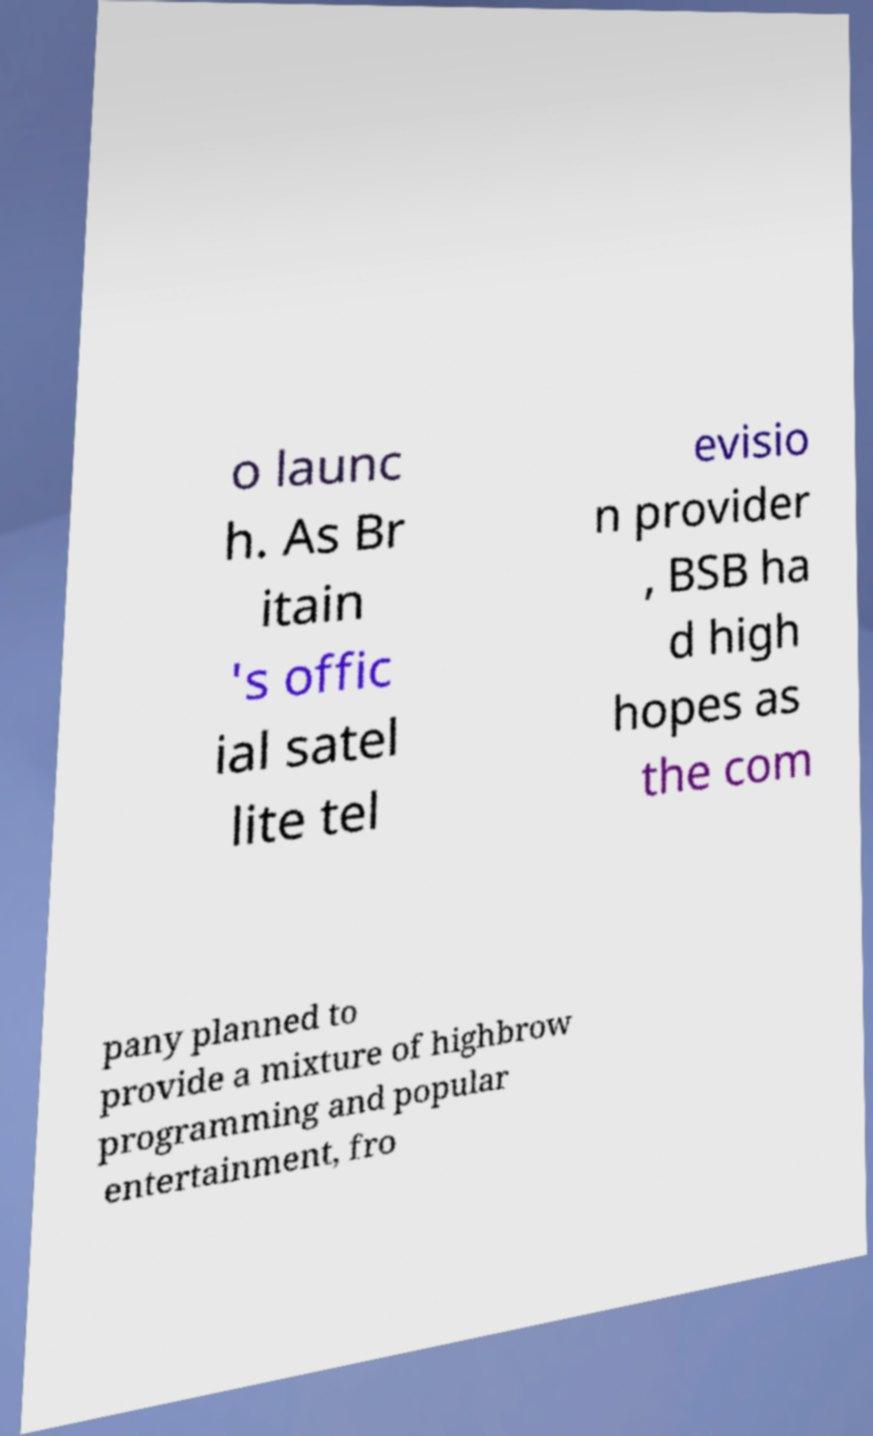Can you accurately transcribe the text from the provided image for me? o launc h. As Br itain 's offic ial satel lite tel evisio n provider , BSB ha d high hopes as the com pany planned to provide a mixture of highbrow programming and popular entertainment, fro 